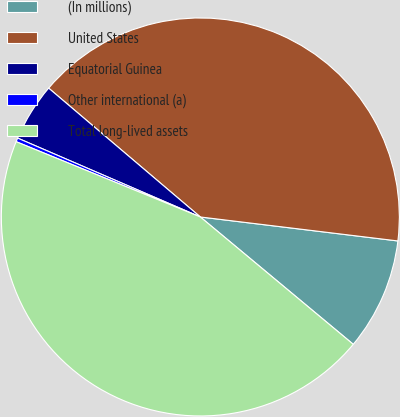<chart> <loc_0><loc_0><loc_500><loc_500><pie_chart><fcel>(In millions)<fcel>United States<fcel>Equatorial Guinea<fcel>Other international (a)<fcel>Total long-lived assets<nl><fcel>9.13%<fcel>40.72%<fcel>4.72%<fcel>0.31%<fcel>45.13%<nl></chart> 